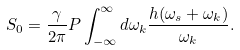Convert formula to latex. <formula><loc_0><loc_0><loc_500><loc_500>S _ { 0 } = \frac { \gamma } { 2 \pi } P \int _ { - \infty } ^ { \infty } d \omega _ { k } \frac { h ( \omega _ { s } + \omega _ { k } ) } { \omega _ { k } } .</formula> 